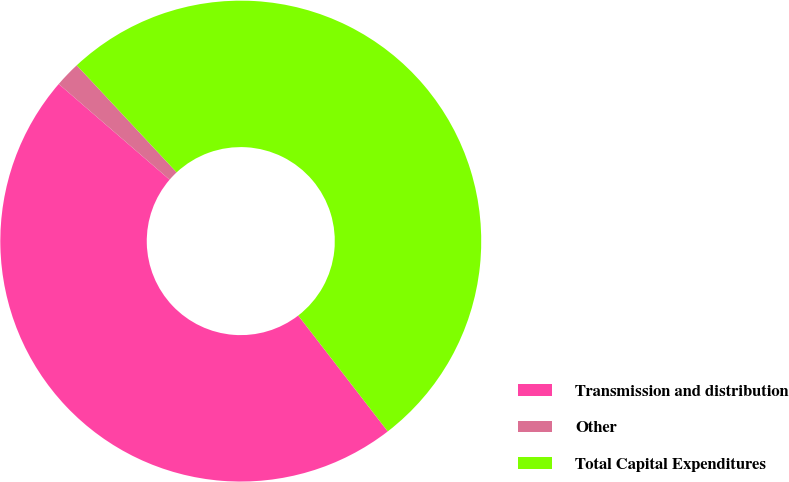Convert chart to OTSL. <chart><loc_0><loc_0><loc_500><loc_500><pie_chart><fcel>Transmission and distribution<fcel>Other<fcel>Total Capital Expenditures<nl><fcel>46.8%<fcel>1.72%<fcel>51.48%<nl></chart> 